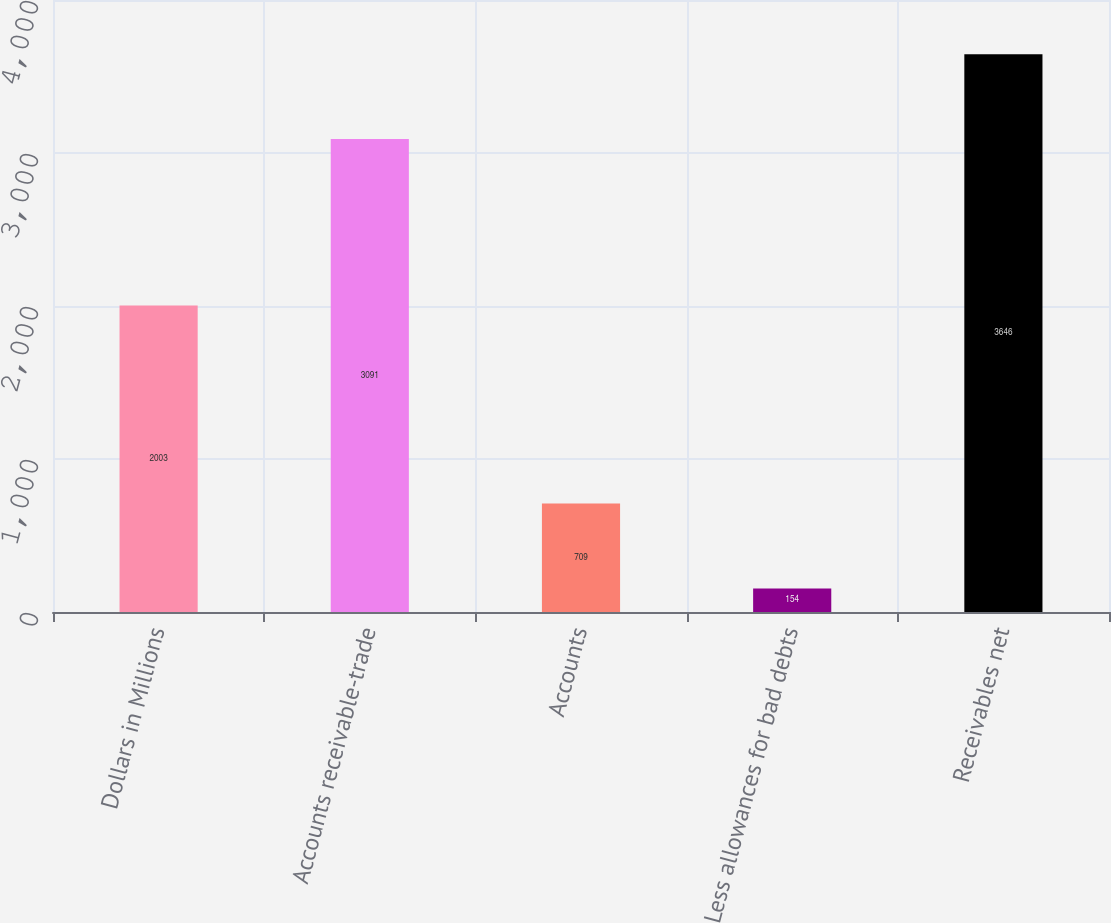Convert chart. <chart><loc_0><loc_0><loc_500><loc_500><bar_chart><fcel>Dollars in Millions<fcel>Accounts receivable-trade<fcel>Accounts<fcel>Less allowances for bad debts<fcel>Receivables net<nl><fcel>2003<fcel>3091<fcel>709<fcel>154<fcel>3646<nl></chart> 